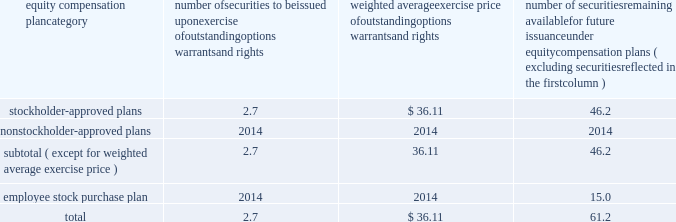Bhge 2018 form 10-k | 107 part iii item 10 .
Directors , executive officers and corporate governance information regarding our code of conduct , the spirit and the letter , and code of ethical conduct certificates for our principal executive officer , principal financial officer and principal accounting officer are described in item 1 .
Business of this annual report .
Information concerning our directors is set forth in the sections entitled "proposal no .
1 , election of directors - board nominees for directors" and "corporate governance - committees of the board" in our definitive proxy statement for the 2019 annual meeting of stockholders to be filed with the sec pursuant to the exchange act within 120 days of the end of our fiscal year on december 31 , 2018 ( proxy statement ) , which sections are incorporated herein by reference .
For information regarding our executive officers , see "item 1 .
Business - executive officers of baker hughes" in this annual report on form 10-k .
Additional information regarding compliance by directors and executive officers with section 16 ( a ) of the exchange act is set forth under the section entitled "section 16 ( a ) beneficial ownership reporting compliance" in our proxy statement , which section is incorporated herein by reference .
Item 11 .
Executive compensation information for this item is set forth in the following sections of our proxy statement , which sections are incorporated herein by reference : "compensation discussion and analysis" "director compensation" "compensation committee interlocks and insider participation" and "compensation committee report." item 12 .
Security ownership of certain beneficial owners and management and related stockholder matters information concerning security ownership of certain beneficial owners and our management is set forth in the sections entitled "stock ownership of certain beneficial owners" and 201cstock ownership of section 16 ( a ) director and executive officers 201d in our proxy statement , which sections are incorporated herein by reference .
We permit our employees , officers and directors to enter into written trading plans complying with rule 10b5-1 under the exchange act .
Rule 10b5-1 provides criteria under which such an individual may establish a prearranged plan to buy or sell a specified number of shares of a company's stock over a set period of time .
Any such plan must be entered into in good faith at a time when the individual is not in possession of material , nonpublic information .
If an individual establishes a plan satisfying the requirements of rule 10b5-1 , such individual's subsequent receipt of material , nonpublic information will not prevent transactions under the plan from being executed .
Certain of our officers have advised us that they have and may enter into stock sales plans for the sale of shares of our class a common stock which are intended to comply with the requirements of rule 10b5-1 of the exchange act .
In addition , the company has and may in the future enter into repurchases of our class a common stock under a plan that complies with rule 10b5-1 or rule 10b-18 of the exchange act .
Equity compensation plan information the information in the table is presented as of december 31 , 2018 with respect to shares of our class a common stock that may be issued under our lti plan which has been approved by our stockholders ( in millions , except per share prices ) .
Equity compensation plan category number of securities to be issued upon exercise of outstanding options , warrants and rights weighted average exercise price of outstanding options , warrants and rights number of securities remaining available for future issuance under equity compensation plans ( excluding securities reflected in the first column ) .

What portion of the total securities approved by stockholders is oustanding? 
Computations: (2.7 + 46.2)
Answer: 48.9. 